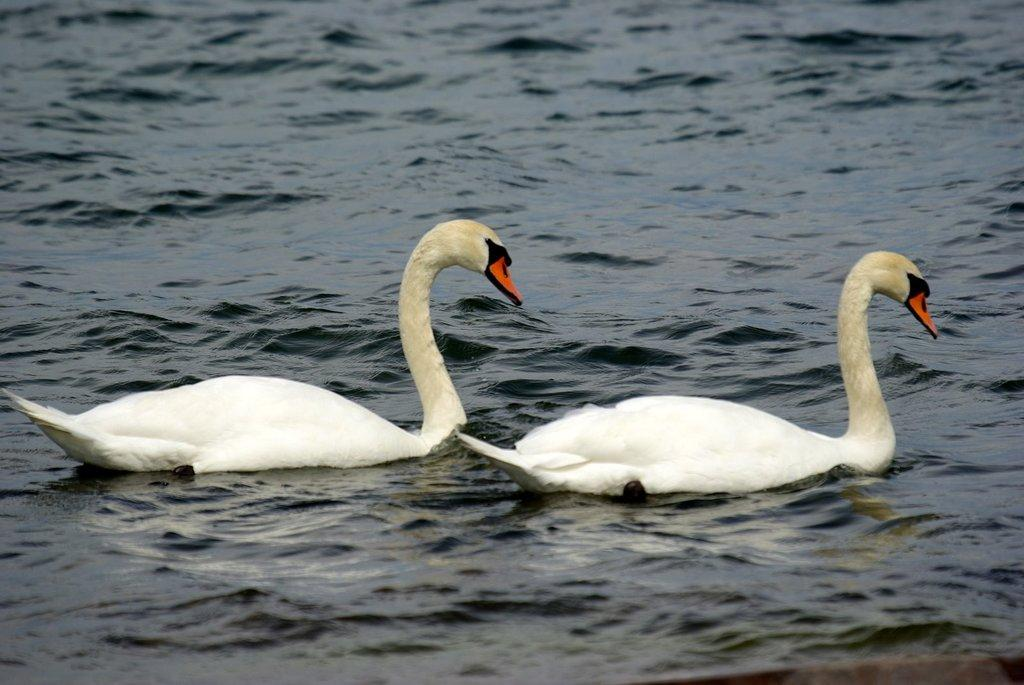What type of animals are in the image? There are ducks in the image. Where are the ducks located? The ducks are on the water. What type of cushion is floating next to the ducks in the image? There is no cushion present in the image; it only features ducks on the water. 